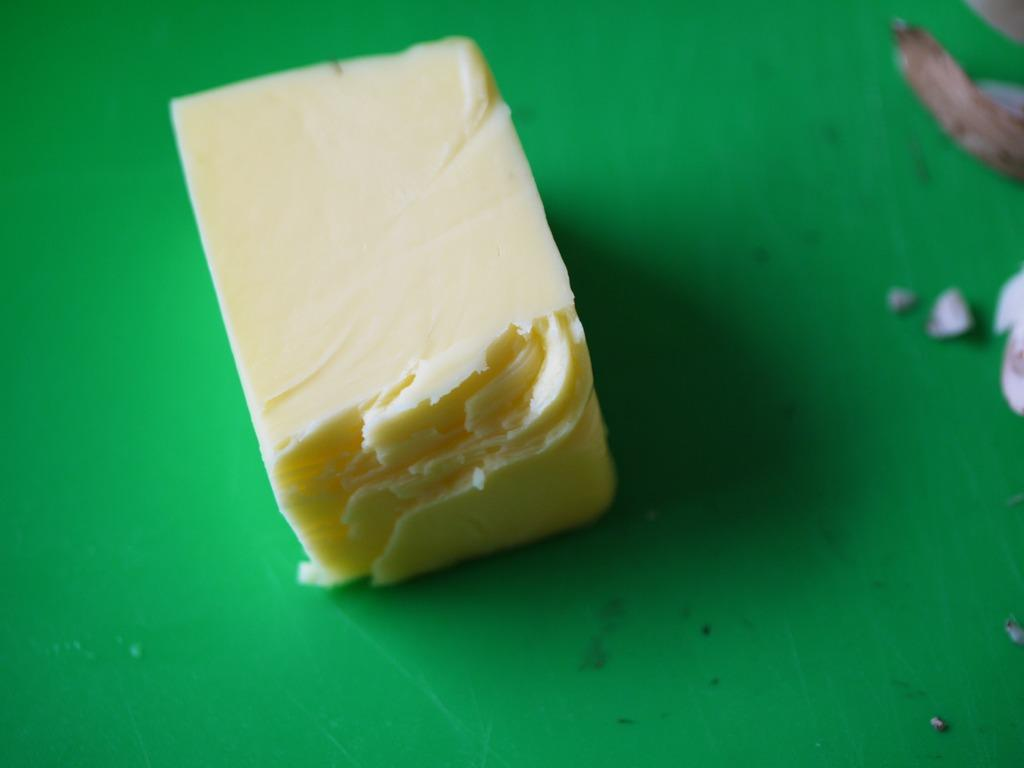What is the color of the surface in the image? The surface in the image is green. What is placed on the green surface? There is a block of butter on the green surface. How many pigs are visible on the green surface in the image? There are no pigs visible on the green surface in the image. What type of plants can be seen growing on the green surface? There are no plants visible on the green surface in the image. 